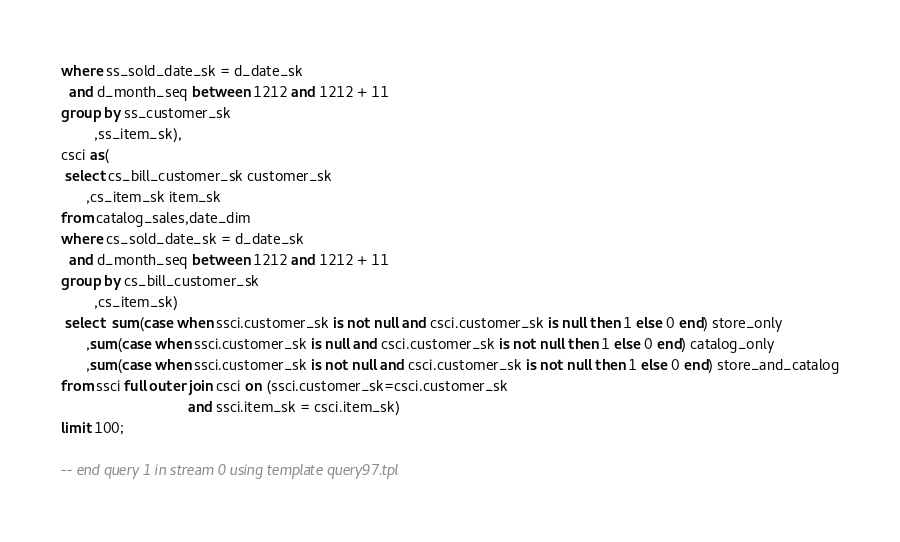<code> <loc_0><loc_0><loc_500><loc_500><_SQL_>where ss_sold_date_sk = d_date_sk
  and d_month_seq between 1212 and 1212 + 11
group by ss_customer_sk
        ,ss_item_sk),
csci as(
 select cs_bill_customer_sk customer_sk
      ,cs_item_sk item_sk
from catalog_sales,date_dim
where cs_sold_date_sk = d_date_sk
  and d_month_seq between 1212 and 1212 + 11
group by cs_bill_customer_sk
        ,cs_item_sk)
 select  sum(case when ssci.customer_sk is not null and csci.customer_sk is null then 1 else 0 end) store_only
      ,sum(case when ssci.customer_sk is null and csci.customer_sk is not null then 1 else 0 end) catalog_only
      ,sum(case when ssci.customer_sk is not null and csci.customer_sk is not null then 1 else 0 end) store_and_catalog
from ssci full outer join csci on (ssci.customer_sk=csci.customer_sk
                               and ssci.item_sk = csci.item_sk)
limit 100;

-- end query 1 in stream 0 using template query97.tpl
</code> 